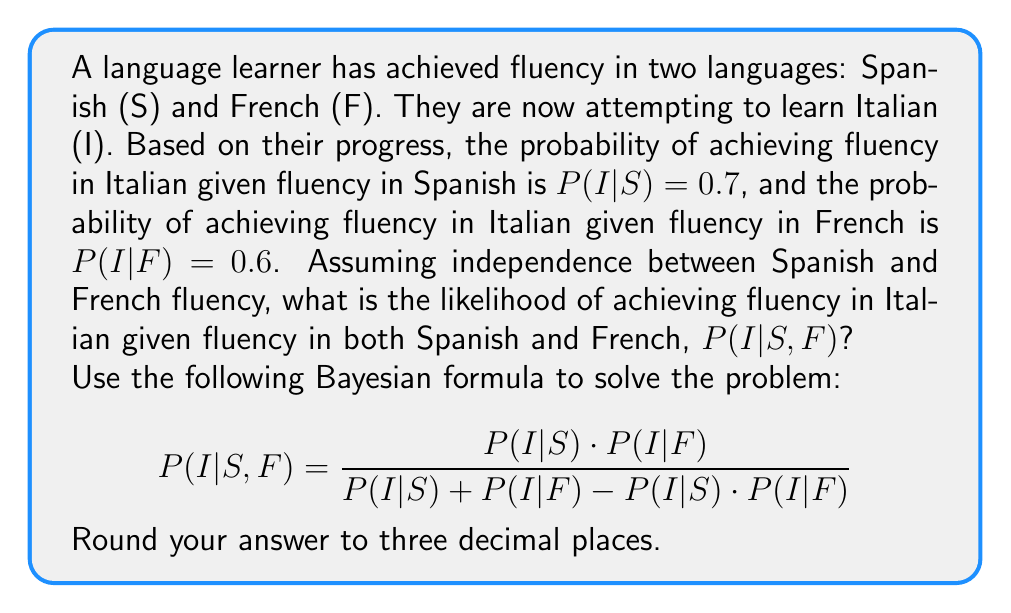Provide a solution to this math problem. To solve this problem, we'll use the given Bayesian formula and the provided probabilities. Let's break it down step-by-step:

1. Given:
   P(I|S) = 0.7
   P(I|F) = 0.6

2. Substitute these values into the formula:

   $$P(I|S,F) = \frac{P(I|S) \cdot P(I|F)}{P(I|S) + P(I|F) - P(I|S) \cdot P(I|F)}$$

3. Calculate the numerator:
   $P(I|S) \cdot P(I|F) = 0.7 \cdot 0.6 = 0.42$

4. Calculate the denominator:
   $P(I|S) + P(I|F) - P(I|S) \cdot P(I|F) = 0.7 + 0.6 - 0.42 = 0.88$

5. Divide the numerator by the denominator:
   $$P(I|S,F) = \frac{0.42}{0.88} = 0.4772727...$$

6. Round the result to three decimal places:
   $P(I|S,F) \approx 0.477$

Therefore, the likelihood of achieving fluency in Italian given fluency in both Spanish and French is approximately 0.477 or 47.7%.
Answer: 0.477 